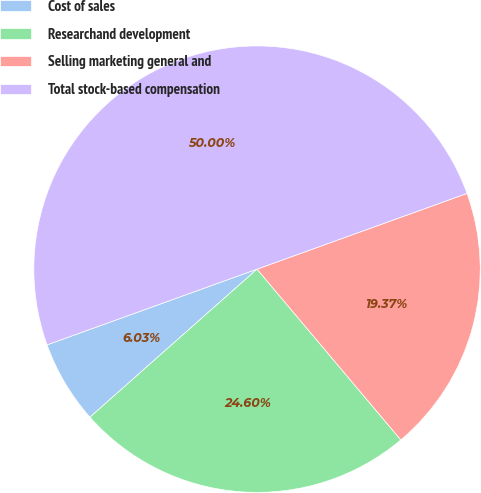Convert chart to OTSL. <chart><loc_0><loc_0><loc_500><loc_500><pie_chart><fcel>Cost of sales<fcel>Researchand development<fcel>Selling marketing general and<fcel>Total stock-based compensation<nl><fcel>6.03%<fcel>24.6%<fcel>19.37%<fcel>50.0%<nl></chart> 